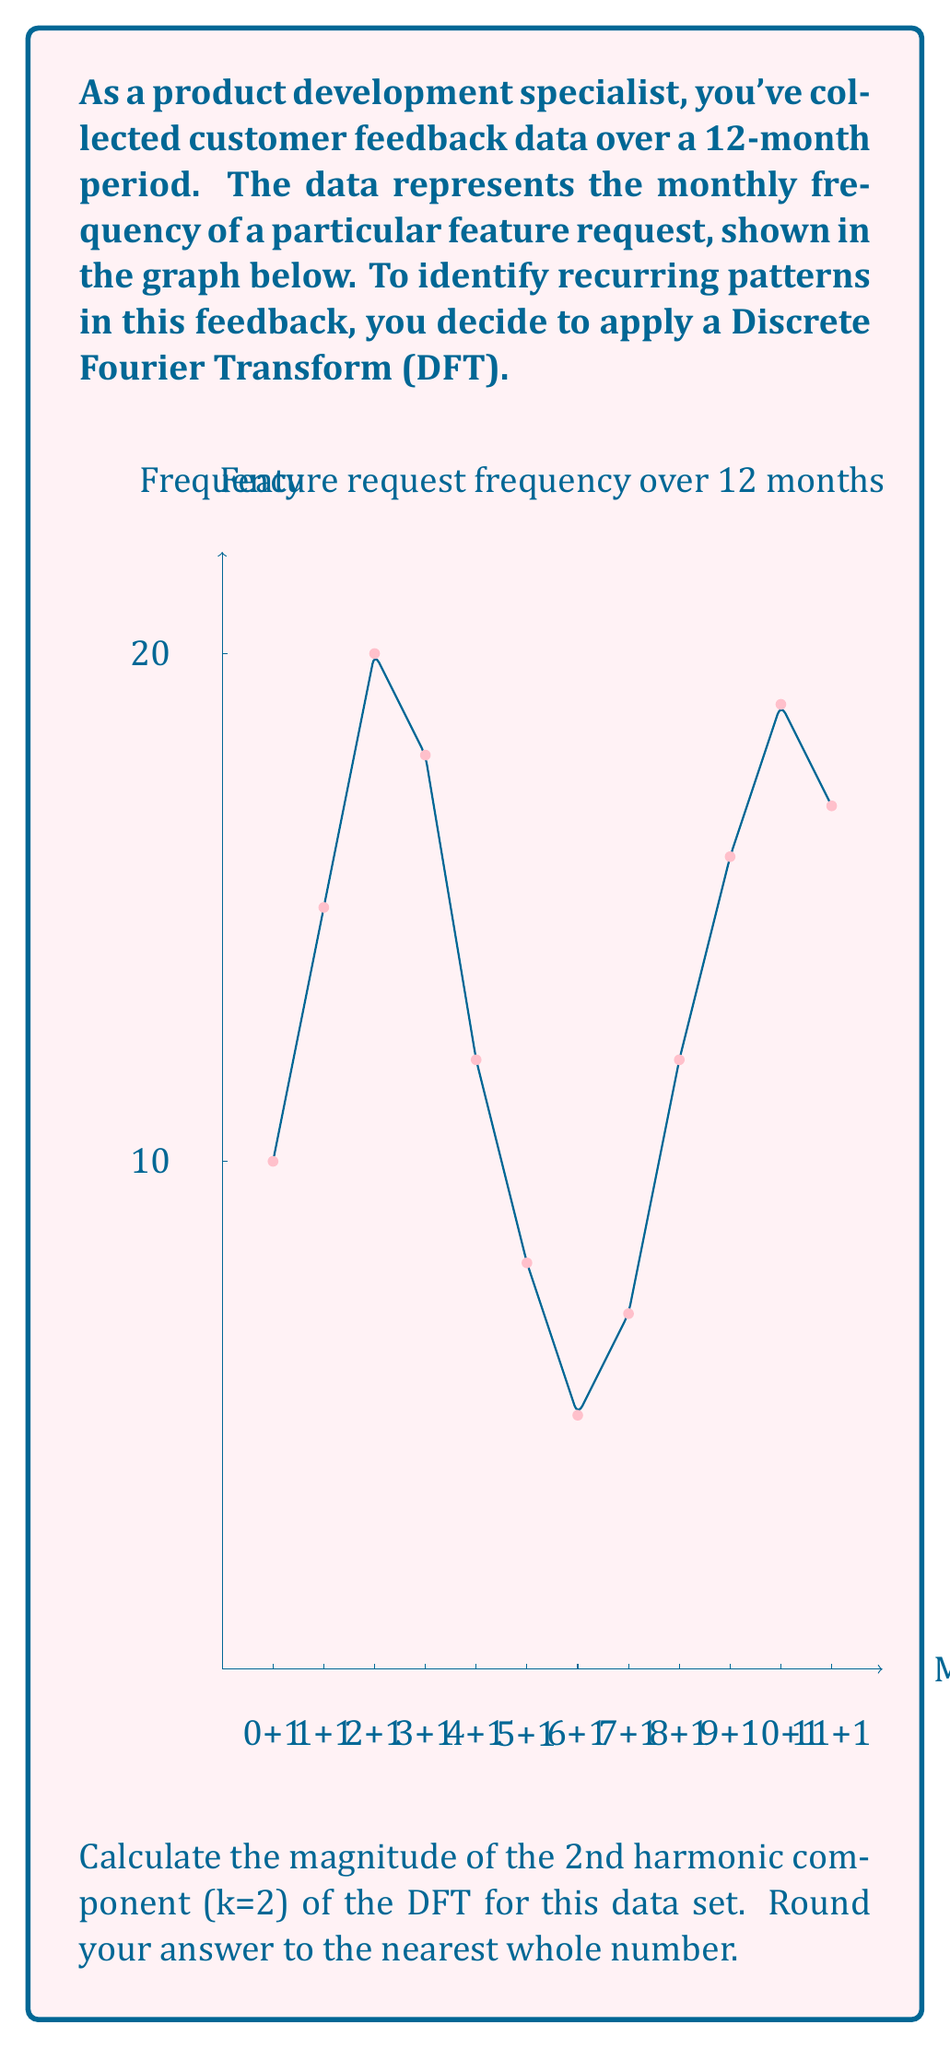Provide a solution to this math problem. To solve this problem, we'll follow these steps:

1) The Discrete Fourier Transform (DFT) for a sequence x[n] of length N is given by:

   $$X[k] = \sum_{n=0}^{N-1} x[n] \cdot e^{-i2\pi kn/N}$$

2) For k=2 and N=12, this becomes:

   $$X[2] = \sum_{n=0}^{11} x[n] \cdot e^{-i2\pi 2n/12}$$

3) We can expand this using Euler's formula:

   $$X[2] = \sum_{n=0}^{11} x[n] \cdot (\cos(2\pi 2n/12) - i\sin(2\pi 2n/12))$$

4) Let's separate the real and imaginary parts:

   $$Re\{X[2]\} = \sum_{n=0}^{11} x[n] \cdot \cos(2\pi 2n/12)$$
   $$Im\{X[2]\} = -\sum_{n=0}^{11} x[n] \cdot \sin(2\pi 2n/12)$$

5) Now, let's calculate these sums using the given data:

   $$Re\{X[2]\} = 10\cos(0) + 15\cos(\pi/3) + 20\cos(2\pi/3) + ... + 17\cos(11\pi/3)$$
   $$Im\{X[2]\} = -10\sin(0) - 15\sin(\pi/3) - 20\sin(2\pi/3) - ... - 17\sin(11\pi/3)$$

6) Calculating these sums:

   $$Re\{X[2]\} \approx -4.50$$
   $$Im\{X[2]\} \approx -7.79$$

7) The magnitude of X[2] is given by:

   $$|X[2]| = \sqrt{(Re\{X[2]\})^2 + (Im\{X[2]\})^2}$$

8) Plugging in our values:

   $$|X[2]| = \sqrt{(-4.50)^2 + (-7.79)^2} \approx 8.98$$

9) Rounding to the nearest whole number:

   $$|X[2]| \approx 9$$
Answer: 9 